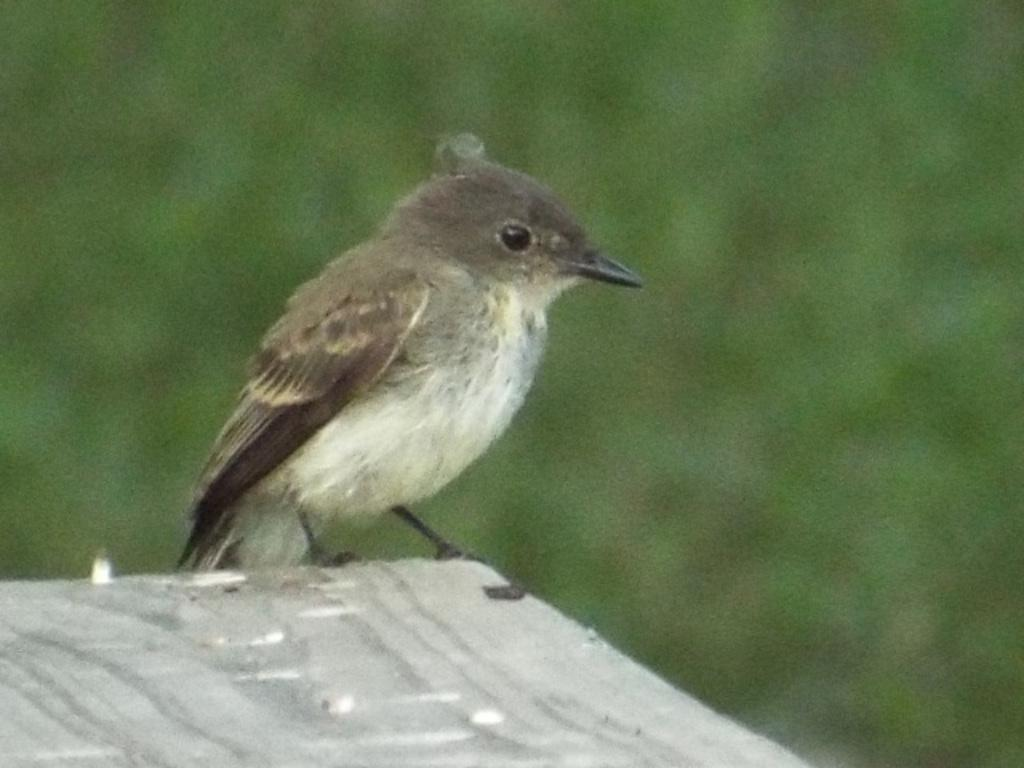What type of animal is present in the image? There is a bird in the image. Can you describe the background of the image? The background of the image is blurred. What type of sound does the bird's brain make in the image? The bird's brain does not make any sound in the image, as brains do not produce sounds. Is there a whistle visible in the image? There is no whistle present in the image. 